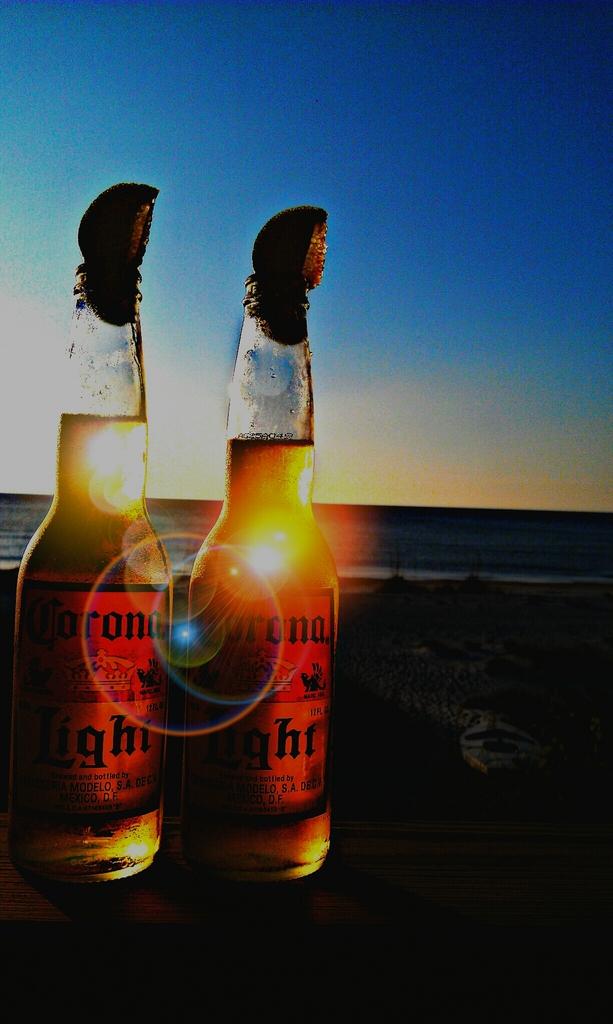What kind of beer is it?
Offer a very short reply. Corona. 